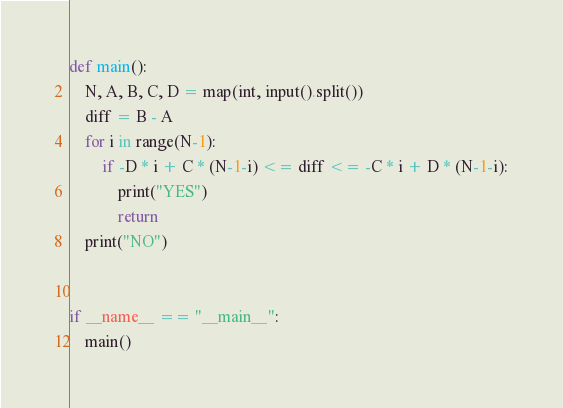Convert code to text. <code><loc_0><loc_0><loc_500><loc_500><_Python_>def main():
    N, A, B, C, D = map(int, input().split())
    diff = B - A
    for i in range(N-1):
        if -D * i + C * (N-1-i) <= diff <= -C * i + D * (N-1-i):
            print("YES")
            return
    print("NO")


if __name__ == "__main__":
    main()
</code> 